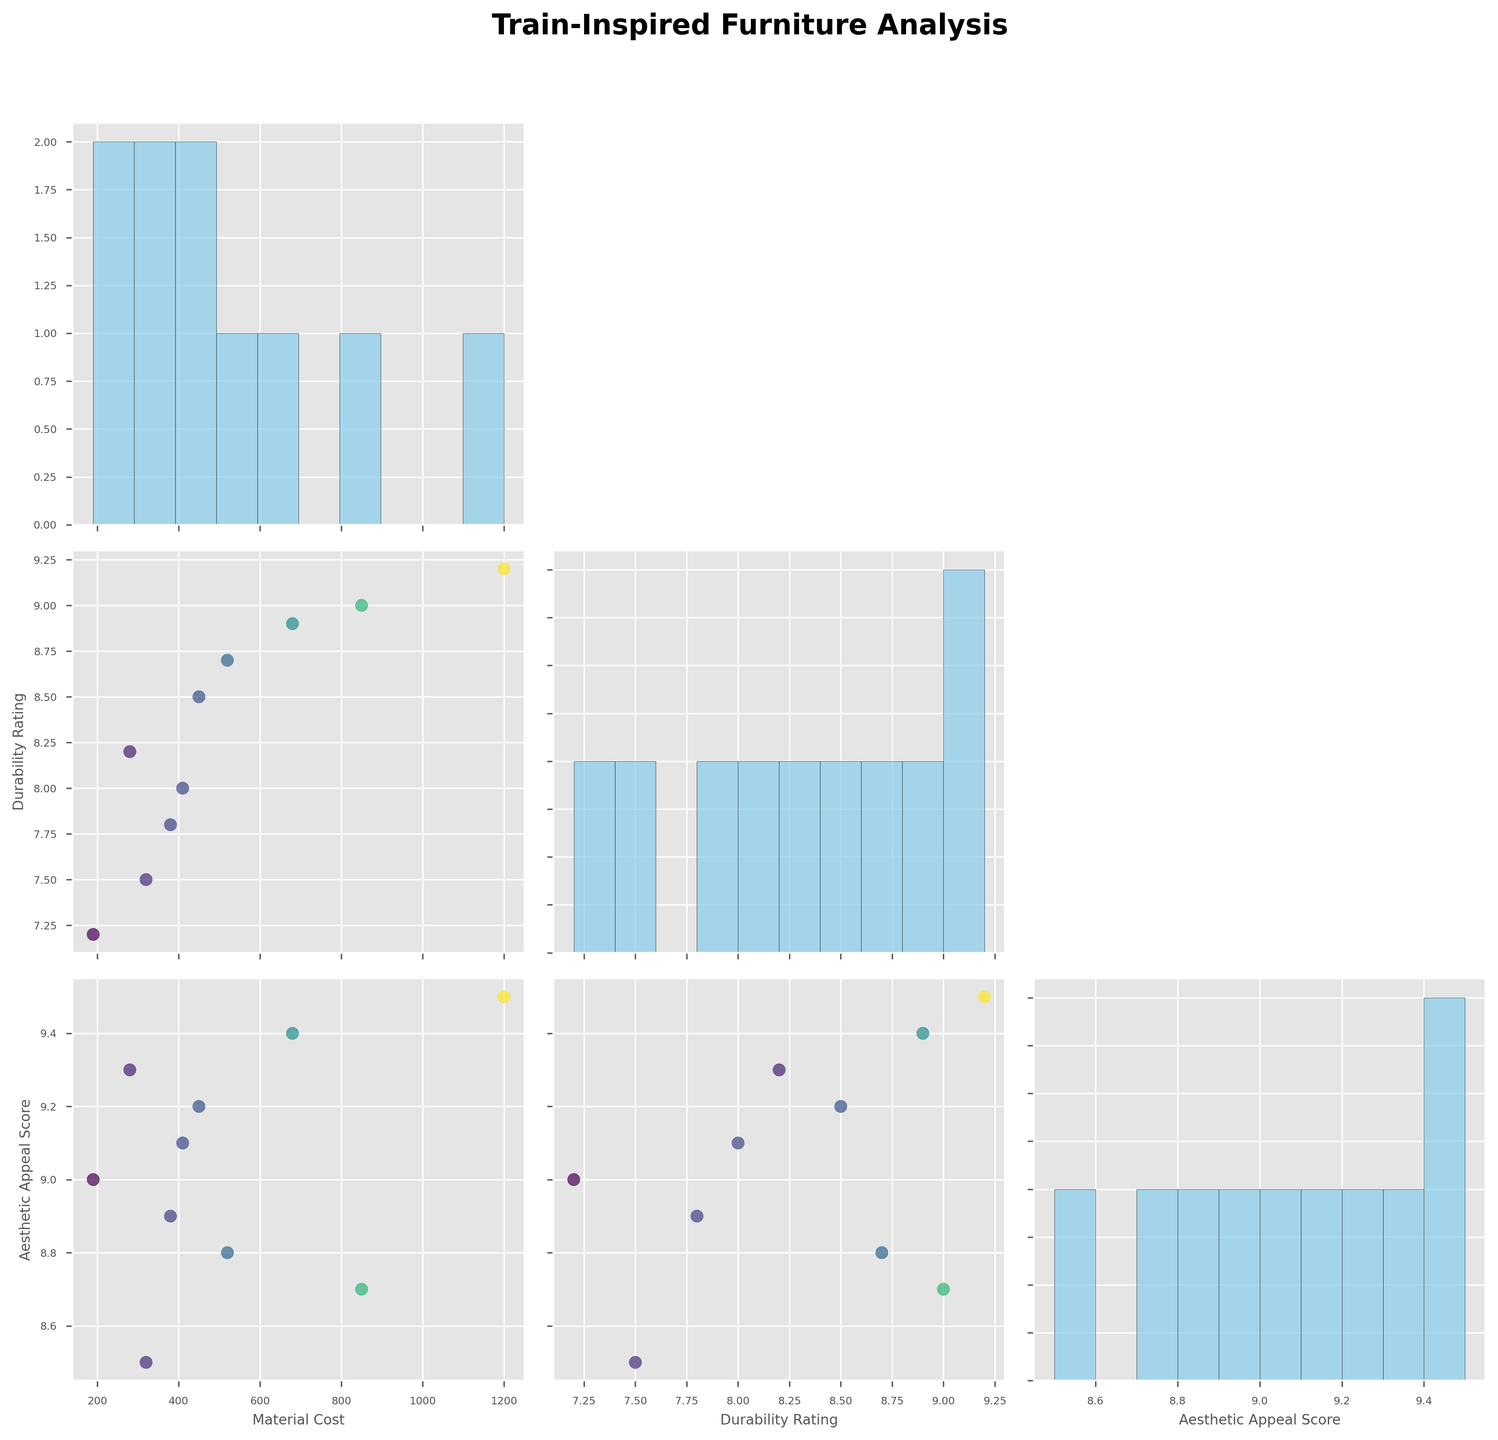what's the title of the figure? The title is usually placed at the top of the figure to summarize what the figure is about. In this case, it is directly mentioned in the code as "Train-Inspired Furniture Analysis".
Answer: Train-Inspired Furniture Analysis how many variables are plotted in the scatterplot matrix? Each column represents a variable plotted in the scatterplot matrix. We can see from the list of features that there are three: Material Cost, Durability Rating, and Aesthetic Appeal Score.
Answer: 3 which furniture piece has the highest material cost? By looking at the scatterplots where the x or y-axis is Material Cost, you will see that the highest point corresponds to the "Dining Car Dining Set" with a Material Cost of 1200.
Answer: Dining Car Dining Set what is the most common value range for durability ratings? By looking at the histogram on the diagonal for Durability Rating, most values fall between 7.5 and 9.0.
Answer: 7.5 to 9.0 which pair of variables seems to have a stronger correlation: Material Cost and Durability Rating, or Material Cost and Aesthetic Appeal Score? By comparing the scatterplots between these pairs:
- Material Cost vs. Durability Rating shows a clustered pattern with possible high outlier points.
- Material Cost vs. Aesthetic Appeal Score shows a more spread-out pattern with higher scores for higher costs.
Hence, Material Cost and Aesthetic Appeal Score have a stronger visible correlation.
Answer: Material Cost and Aesthetic Appeal Score which variable is depicted in the color gradient of scatter plots? The color gradient of the scatter plots represents "Material Cost", as indicated by the code mentioning c=data['Material_Cost'].
Answer: Material Cost what is the range of aesthetic appeal scores? By examining the histogram on the diagonal for Aesthetic Appeal Score, the values span from approximately 8.5 to 9.5.
Answer: 8.5 to 9.5 is there a large variance in material costs among the furniture pieces? The histogram of Material Cost shows a wide spread of values ranging from about 190 to 1200, indicating a large variance.
Answer: Yes comparing durability ratings and aesthetic appeal scores, which has a higher mean? By looking at the histograms:
- Durability Rating values cluster around 8.
- Aesthetic Appeal Score values cluster around 9.
It's clear that Aesthetic Appeal Score has a higher mean.
Answer: Aesthetic Appeal Score which pair of variables seems to have the least correlation? By examining the scatter plots:
- Material Cost and Durability Rating show a relatively less coherent pattern compared to the other pairs.
So, this pair has the least visible correlation.
Answer: Material Cost and Durability Rating 